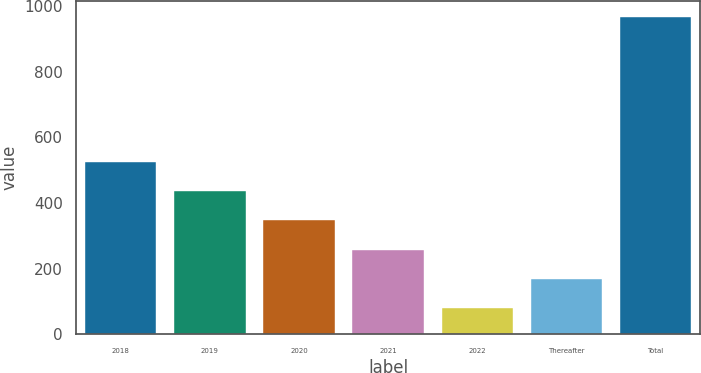Convert chart. <chart><loc_0><loc_0><loc_500><loc_500><bar_chart><fcel>2018<fcel>2019<fcel>2020<fcel>2021<fcel>2022<fcel>Thereafter<fcel>Total<nl><fcel>524<fcel>435.4<fcel>346.8<fcel>258.2<fcel>81<fcel>169.6<fcel>967<nl></chart> 